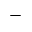<formula> <loc_0><loc_0><loc_500><loc_500>-</formula> 